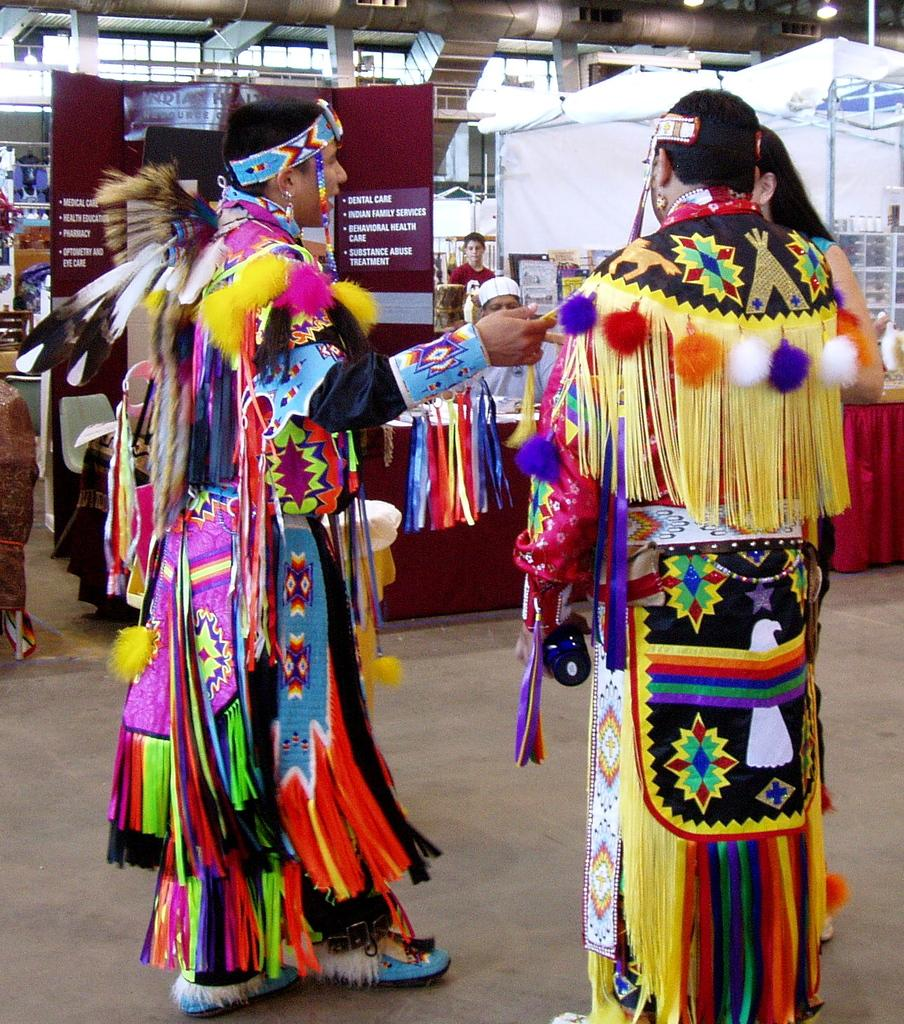What are the persons in the image wearing? The persons in the image are wearing different costumes. What are the persons doing in the image? The persons are standing. What type of furniture can be seen in the image? There are tables in the image. What type of shelter is present in the image? There are umbrella tents in the image. What type of signage is present in the image? There are boards in the image. What type of structure is present in the image? There is a pipeline in the image. What type of church can be seen in the image? There is no church present in the image. What is the angle of the slope in the image? There is no slope present in the image. 